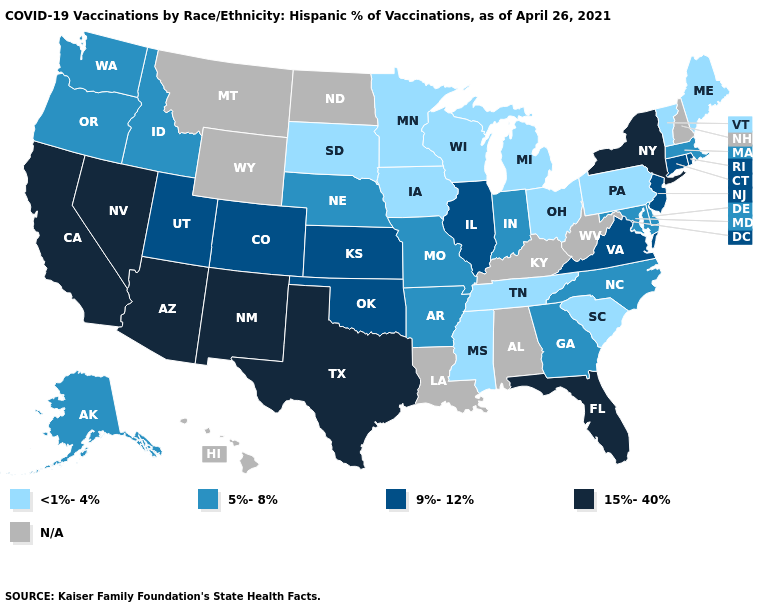Which states have the highest value in the USA?
Answer briefly. Arizona, California, Florida, Nevada, New Mexico, New York, Texas. Among the states that border Vermont , does Massachusetts have the lowest value?
Be succinct. Yes. Does Vermont have the lowest value in the Northeast?
Be succinct. Yes. What is the value of Nebraska?
Quick response, please. 5%-8%. Among the states that border Oregon , does Nevada have the highest value?
Give a very brief answer. Yes. Does the map have missing data?
Give a very brief answer. Yes. Does Kansas have the highest value in the MidWest?
Be succinct. Yes. Does the first symbol in the legend represent the smallest category?
Answer briefly. Yes. What is the value of Connecticut?
Answer briefly. 9%-12%. What is the value of Utah?
Answer briefly. 9%-12%. Which states hav the highest value in the MidWest?
Keep it brief. Illinois, Kansas. 